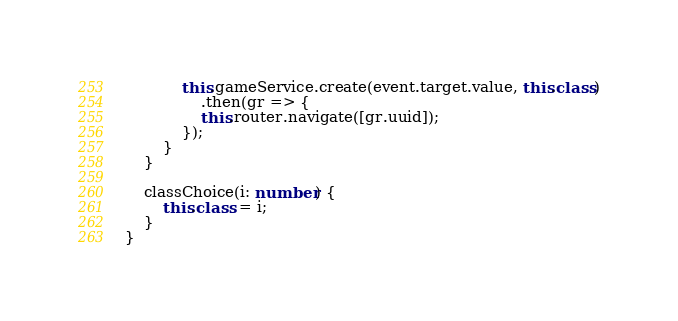Convert code to text. <code><loc_0><loc_0><loc_500><loc_500><_TypeScript_>
            this.gameService.create(event.target.value, this.class)
                .then(gr => {
                this.router.navigate([gr.uuid]);
            });
        }
    }

    classChoice(i: number) {
        this.class = i;
    }
}
</code> 